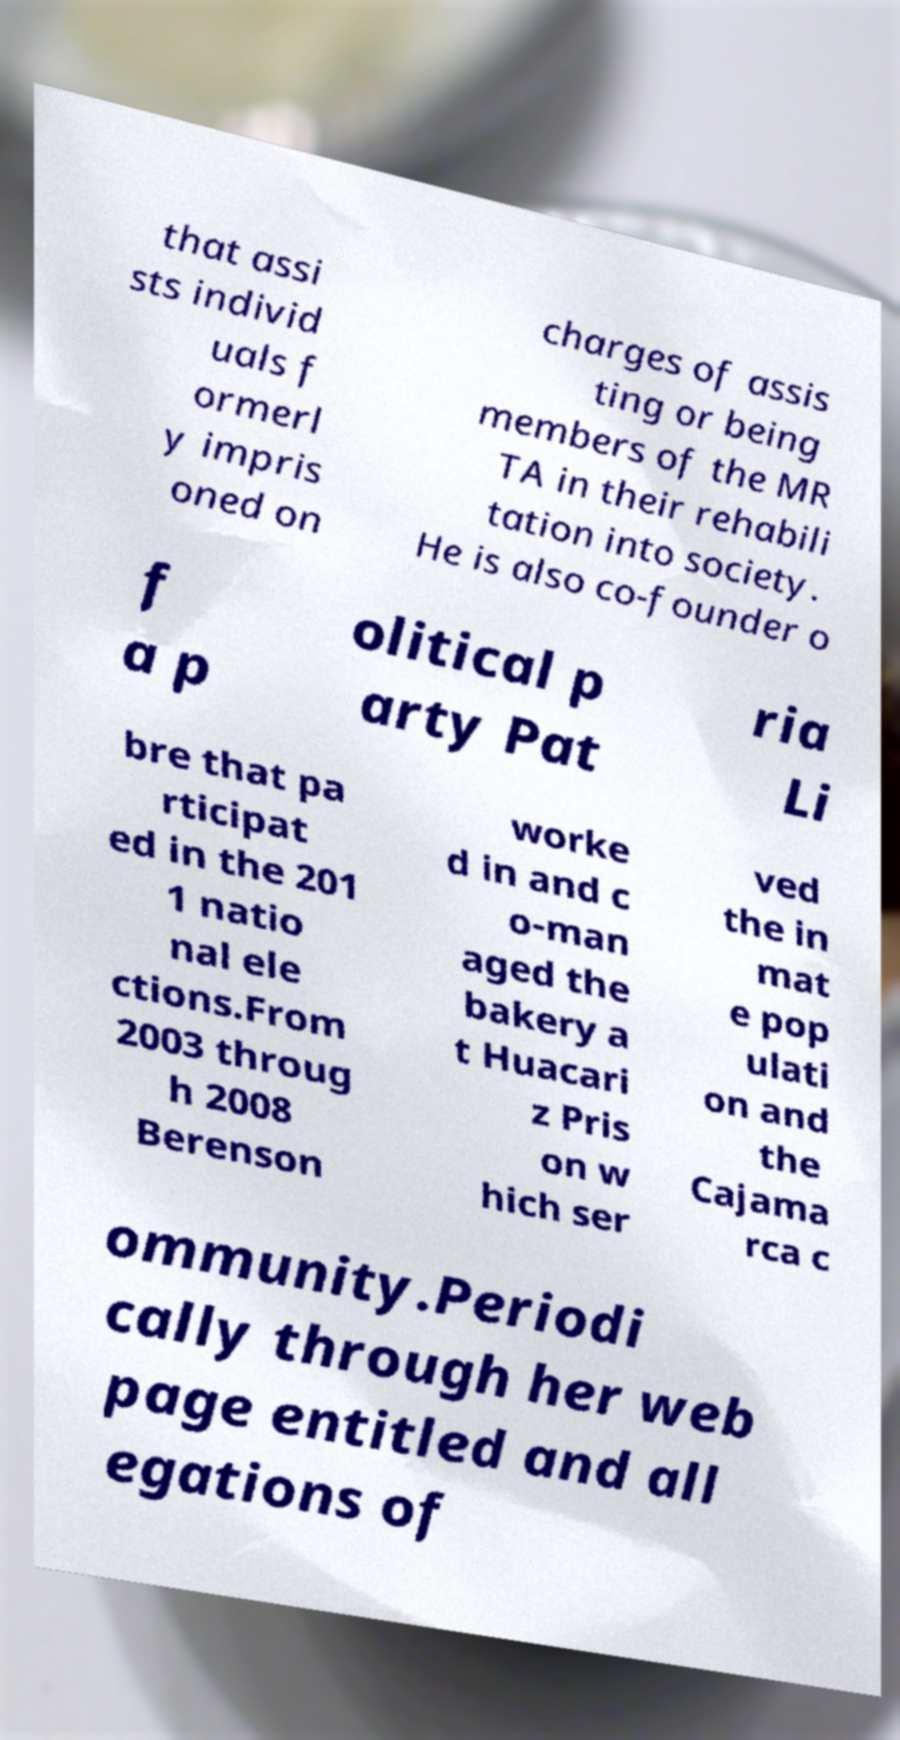There's text embedded in this image that I need extracted. Can you transcribe it verbatim? that assi sts individ uals f ormerl y impris oned on charges of assis ting or being members of the MR TA in their rehabili tation into society. He is also co-founder o f a p olitical p arty Pat ria Li bre that pa rticipat ed in the 201 1 natio nal ele ctions.From 2003 throug h 2008 Berenson worke d in and c o-man aged the bakery a t Huacari z Pris on w hich ser ved the in mat e pop ulati on and the Cajama rca c ommunity.Periodi cally through her web page entitled and all egations of 